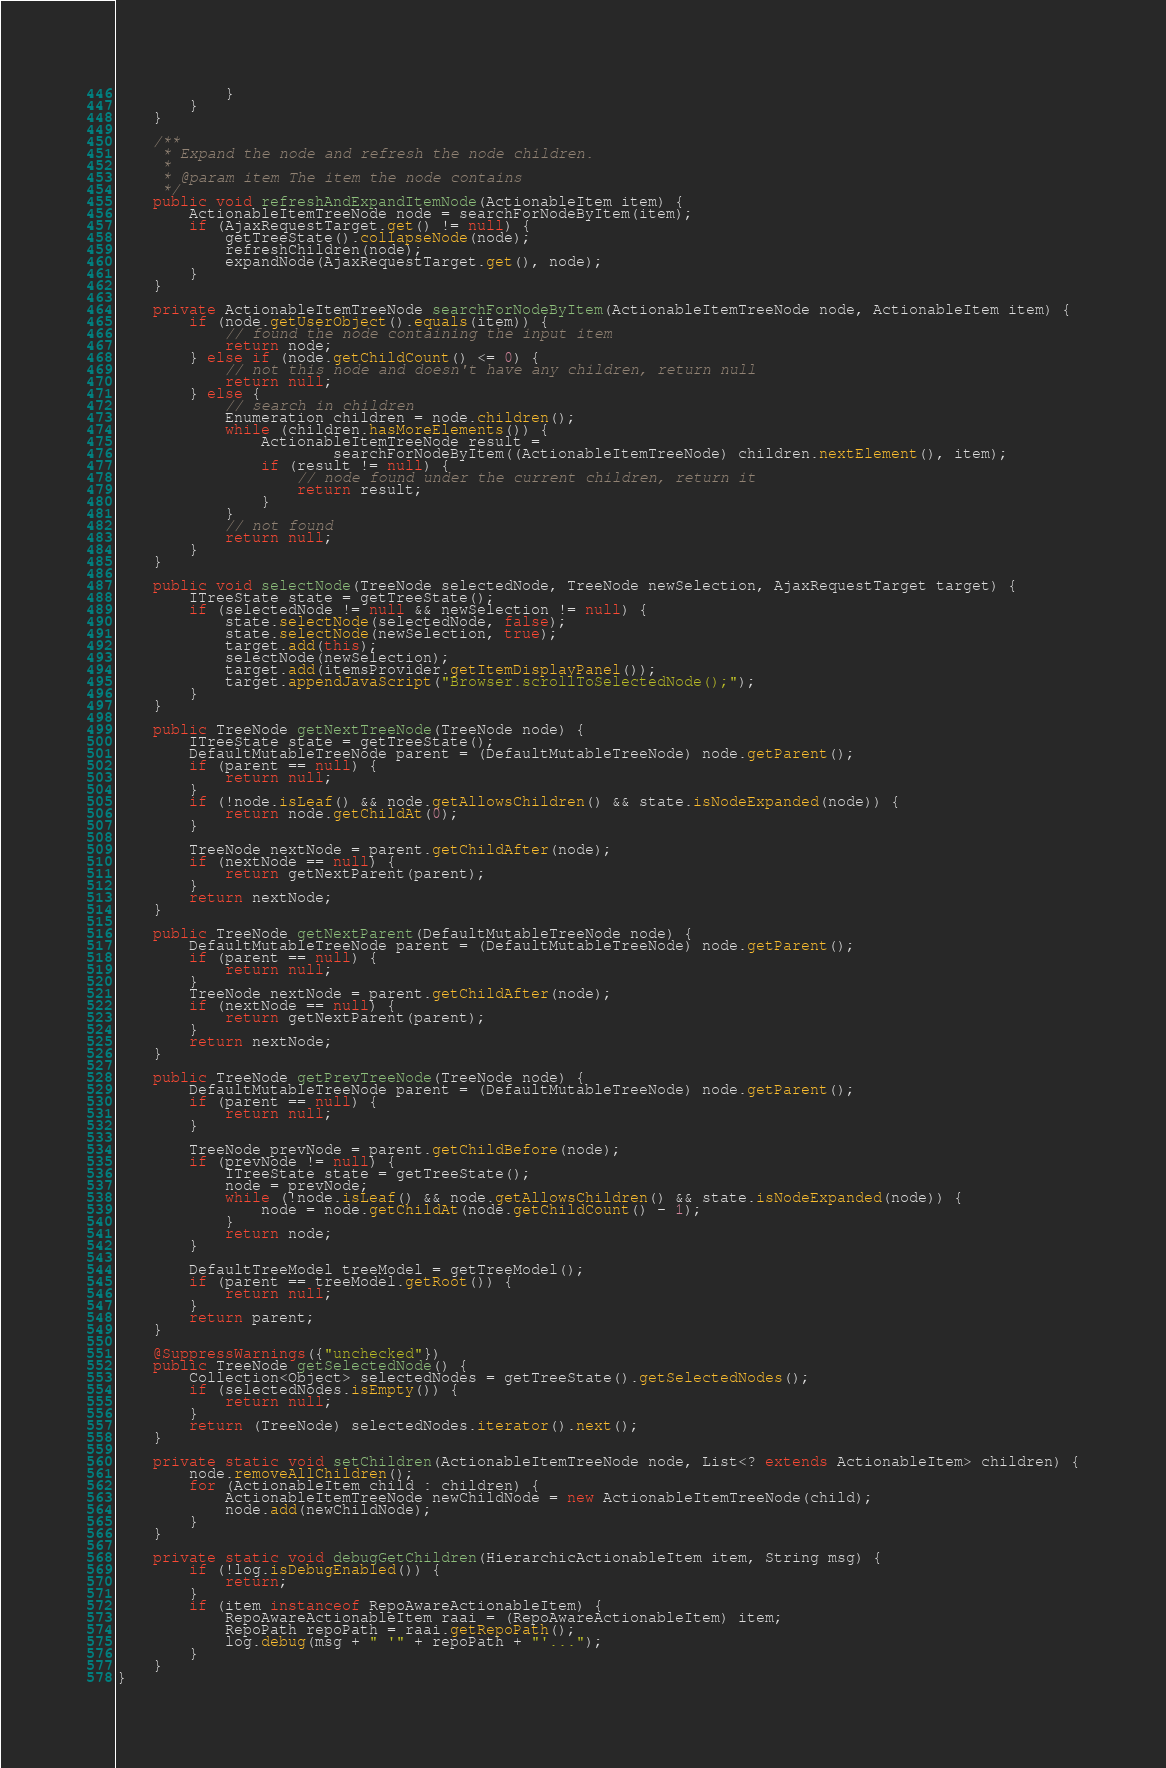Convert code to text. <code><loc_0><loc_0><loc_500><loc_500><_Java_>            }
        }
    }

    /**
     * Expand the node and refresh the node children.
     *
     * @param item The item the node contains
     */
    public void refreshAndExpandItemNode(ActionableItem item) {
        ActionableItemTreeNode node = searchForNodeByItem(item);
        if (AjaxRequestTarget.get() != null) {
            getTreeState().collapseNode(node);
            refreshChildren(node);
            expandNode(AjaxRequestTarget.get(), node);
        }
    }

    private ActionableItemTreeNode searchForNodeByItem(ActionableItemTreeNode node, ActionableItem item) {
        if (node.getUserObject().equals(item)) {
            // found the node containing the input item
            return node;
        } else if (node.getChildCount() <= 0) {
            // not this node and doesn't have any children, return null
            return null;
        } else {
            // search in children
            Enumeration children = node.children();
            while (children.hasMoreElements()) {
                ActionableItemTreeNode result =
                        searchForNodeByItem((ActionableItemTreeNode) children.nextElement(), item);
                if (result != null) {
                    // node found under the current children, return it
                    return result;
                }
            }
            // not found
            return null;
        }
    }

    public void selectNode(TreeNode selectedNode, TreeNode newSelection, AjaxRequestTarget target) {
        ITreeState state = getTreeState();
        if (selectedNode != null && newSelection != null) {
            state.selectNode(selectedNode, false);
            state.selectNode(newSelection, true);
            target.add(this);
            selectNode(newSelection);
            target.add(itemsProvider.getItemDisplayPanel());
            target.appendJavaScript("Browser.scrollToSelectedNode();");
        }
    }

    public TreeNode getNextTreeNode(TreeNode node) {
        ITreeState state = getTreeState();
        DefaultMutableTreeNode parent = (DefaultMutableTreeNode) node.getParent();
        if (parent == null) {
            return null;
        }
        if (!node.isLeaf() && node.getAllowsChildren() && state.isNodeExpanded(node)) {
            return node.getChildAt(0);
        }

        TreeNode nextNode = parent.getChildAfter(node);
        if (nextNode == null) {
            return getNextParent(parent);
        }
        return nextNode;
    }

    public TreeNode getNextParent(DefaultMutableTreeNode node) {
        DefaultMutableTreeNode parent = (DefaultMutableTreeNode) node.getParent();
        if (parent == null) {
            return null;
        }
        TreeNode nextNode = parent.getChildAfter(node);
        if (nextNode == null) {
            return getNextParent(parent);
        }
        return nextNode;
    }

    public TreeNode getPrevTreeNode(TreeNode node) {
        DefaultMutableTreeNode parent = (DefaultMutableTreeNode) node.getParent();
        if (parent == null) {
            return null;
        }

        TreeNode prevNode = parent.getChildBefore(node);
        if (prevNode != null) {
            ITreeState state = getTreeState();
            node = prevNode;
            while (!node.isLeaf() && node.getAllowsChildren() && state.isNodeExpanded(node)) {
                node = node.getChildAt(node.getChildCount() - 1);
            }
            return node;
        }

        DefaultTreeModel treeModel = getTreeModel();
        if (parent == treeModel.getRoot()) {
            return null;
        }
        return parent;
    }

    @SuppressWarnings({"unchecked"})
    public TreeNode getSelectedNode() {
        Collection<Object> selectedNodes = getTreeState().getSelectedNodes();
        if (selectedNodes.isEmpty()) {
            return null;
        }
        return (TreeNode) selectedNodes.iterator().next();
    }

    private static void setChildren(ActionableItemTreeNode node, List<? extends ActionableItem> children) {
        node.removeAllChildren();
        for (ActionableItem child : children) {
            ActionableItemTreeNode newChildNode = new ActionableItemTreeNode(child);
            node.add(newChildNode);
        }
    }

    private static void debugGetChildren(HierarchicActionableItem item, String msg) {
        if (!log.isDebugEnabled()) {
            return;
        }
        if (item instanceof RepoAwareActionableItem) {
            RepoAwareActionableItem raai = (RepoAwareActionableItem) item;
            RepoPath repoPath = raai.getRepoPath();
            log.debug(msg + " '" + repoPath + "'...");
        }
    }
}
</code> 